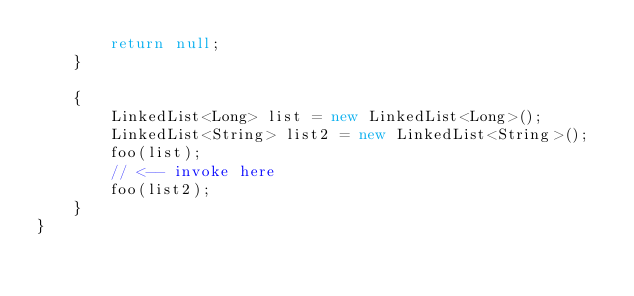Convert code to text. <code><loc_0><loc_0><loc_500><loc_500><_Java_>        return null;
    }

    {
        LinkedList<Long> list = new LinkedList<Long>();
        LinkedList<String> list2 = new LinkedList<String>();
        foo(list);
        // <-- invoke here
        foo(list2);
    }
}
</code> 